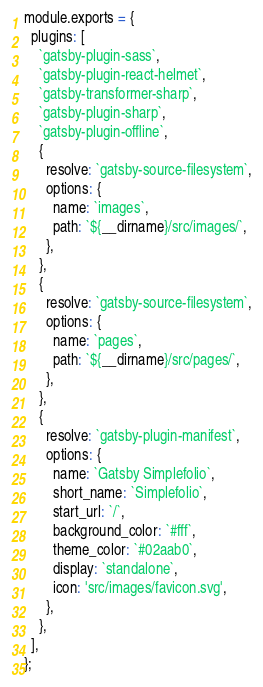Convert code to text. <code><loc_0><loc_0><loc_500><loc_500><_JavaScript_>module.exports = {
  plugins: [
    `gatsby-plugin-sass`,
    `gatsby-plugin-react-helmet`,
    `gatsby-transformer-sharp`,
    `gatsby-plugin-sharp`,
    `gatsby-plugin-offline`,
    {
      resolve: `gatsby-source-filesystem`,
      options: {
        name: `images`,
        path: `${__dirname}/src/images/`,
      },
    },
    {
      resolve: `gatsby-source-filesystem`,
      options: {
        name: `pages`,
        path: `${__dirname}/src/pages/`,
      },
    },
    {
      resolve: `gatsby-plugin-manifest`,
      options: {
        name: `Gatsby Simplefolio`,
        short_name: `Simplefolio`,
        start_url: `/`,
        background_color: `#fff`,
        theme_color: `#02aab0`,
        display: `standalone`,
        icon: 'src/images/favicon.svg',
      },
    },
  ],
};
</code> 